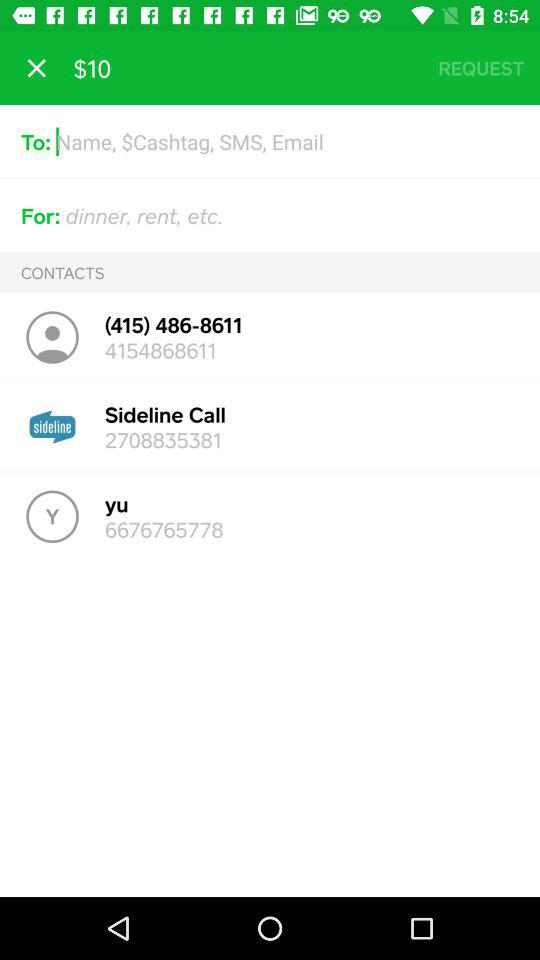What number is shown on the sideline call? The number shown is 2708835381. 